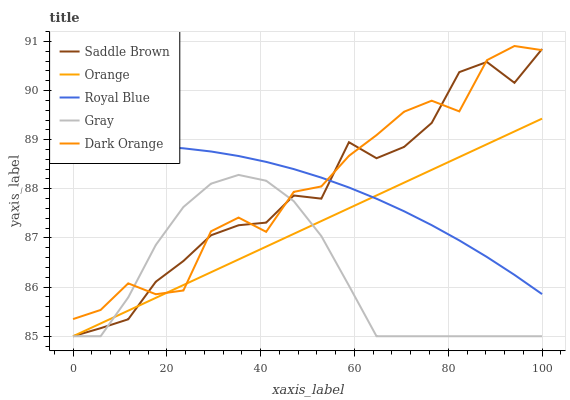Does Gray have the minimum area under the curve?
Answer yes or no. Yes. Does Dark Orange have the maximum area under the curve?
Answer yes or no. Yes. Does Royal Blue have the minimum area under the curve?
Answer yes or no. No. Does Royal Blue have the maximum area under the curve?
Answer yes or no. No. Is Orange the smoothest?
Answer yes or no. Yes. Is Dark Orange the roughest?
Answer yes or no. Yes. Is Royal Blue the smoothest?
Answer yes or no. No. Is Royal Blue the roughest?
Answer yes or no. No. Does Royal Blue have the lowest value?
Answer yes or no. No. Does Dark Orange have the highest value?
Answer yes or no. Yes. Does Royal Blue have the highest value?
Answer yes or no. No. Is Gray less than Royal Blue?
Answer yes or no. Yes. Is Royal Blue greater than Gray?
Answer yes or no. Yes. Does Gray intersect Royal Blue?
Answer yes or no. No. 